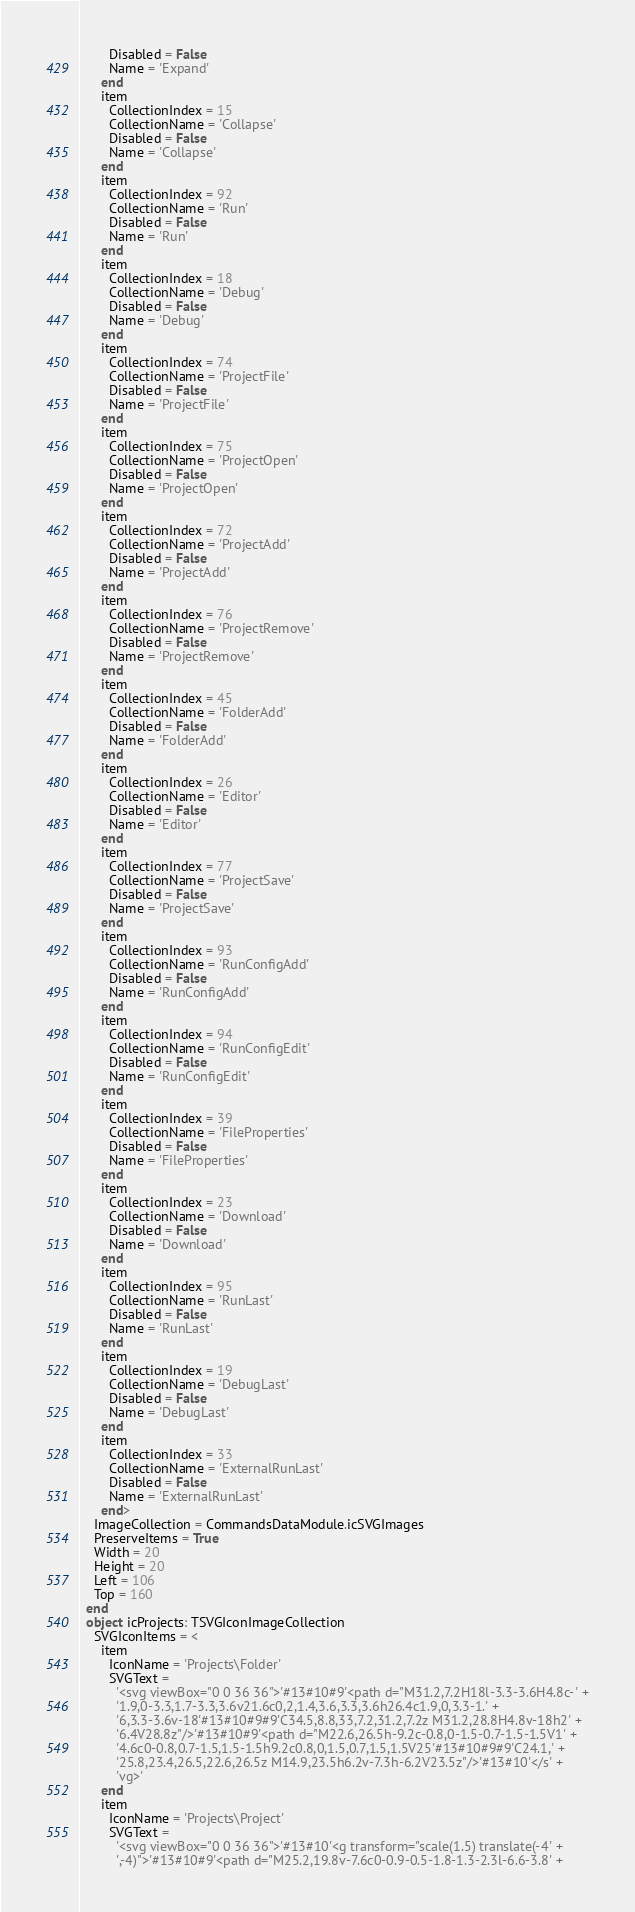Convert code to text. <code><loc_0><loc_0><loc_500><loc_500><_Pascal_>        Disabled = False
        Name = 'Expand'
      end
      item
        CollectionIndex = 15
        CollectionName = 'Collapse'
        Disabled = False
        Name = 'Collapse'
      end
      item
        CollectionIndex = 92
        CollectionName = 'Run'
        Disabled = False
        Name = 'Run'
      end
      item
        CollectionIndex = 18
        CollectionName = 'Debug'
        Disabled = False
        Name = 'Debug'
      end
      item
        CollectionIndex = 74
        CollectionName = 'ProjectFile'
        Disabled = False
        Name = 'ProjectFile'
      end
      item
        CollectionIndex = 75
        CollectionName = 'ProjectOpen'
        Disabled = False
        Name = 'ProjectOpen'
      end
      item
        CollectionIndex = 72
        CollectionName = 'ProjectAdd'
        Disabled = False
        Name = 'ProjectAdd'
      end
      item
        CollectionIndex = 76
        CollectionName = 'ProjectRemove'
        Disabled = False
        Name = 'ProjectRemove'
      end
      item
        CollectionIndex = 45
        CollectionName = 'FolderAdd'
        Disabled = False
        Name = 'FolderAdd'
      end
      item
        CollectionIndex = 26
        CollectionName = 'Editor'
        Disabled = False
        Name = 'Editor'
      end
      item
        CollectionIndex = 77
        CollectionName = 'ProjectSave'
        Disabled = False
        Name = 'ProjectSave'
      end
      item
        CollectionIndex = 93
        CollectionName = 'RunConfigAdd'
        Disabled = False
        Name = 'RunConfigAdd'
      end
      item
        CollectionIndex = 94
        CollectionName = 'RunConfigEdit'
        Disabled = False
        Name = 'RunConfigEdit'
      end
      item
        CollectionIndex = 39
        CollectionName = 'FileProperties'
        Disabled = False
        Name = 'FileProperties'
      end
      item
        CollectionIndex = 23
        CollectionName = 'Download'
        Disabled = False
        Name = 'Download'
      end
      item
        CollectionIndex = 95
        CollectionName = 'RunLast'
        Disabled = False
        Name = 'RunLast'
      end
      item
        CollectionIndex = 19
        CollectionName = 'DebugLast'
        Disabled = False
        Name = 'DebugLast'
      end
      item
        CollectionIndex = 33
        CollectionName = 'ExternalRunLast'
        Disabled = False
        Name = 'ExternalRunLast'
      end>
    ImageCollection = CommandsDataModule.icSVGImages
    PreserveItems = True
    Width = 20
    Height = 20
    Left = 106
    Top = 160
  end
  object icProjects: TSVGIconImageCollection
    SVGIconItems = <
      item
        IconName = 'Projects\Folder'
        SVGText = 
          '<svg viewBox="0 0 36 36">'#13#10#9'<path d="M31.2,7.2H18l-3.3-3.6H4.8c-' +
          '1.9,0-3.3,1.7-3.3,3.6v21.6c0,2,1.4,3.6,3.3,3.6h26.4c1.9,0,3.3-1.' +
          '6,3.3-3.6v-18'#13#10#9#9'C34.5,8.8,33,7.2,31.2,7.2z M31.2,28.8H4.8v-18h2' +
          '6.4V28.8z"/>'#13#10#9'<path d="M22.6,26.5h-9.2c-0.8,0-1.5-0.7-1.5-1.5V1' +
          '4.6c0-0.8,0.7-1.5,1.5-1.5h9.2c0.8,0,1.5,0.7,1.5,1.5V25'#13#10#9#9'C24.1,' +
          '25.8,23.4,26.5,22.6,26.5z M14.9,23.5h6.2v-7.3h-6.2V23.5z"/>'#13#10'</s' +
          'vg>'
      end
      item
        IconName = 'Projects\Project'
        SVGText = 
          '<svg viewBox="0 0 36 36">'#13#10'<g transform="scale(1.5) translate(-4' +
          ',-4)">'#13#10#9'<path d="M25.2,19.8v-7.6c0-0.9-0.5-1.8-1.3-2.3l-6.6-3.8' +</code> 